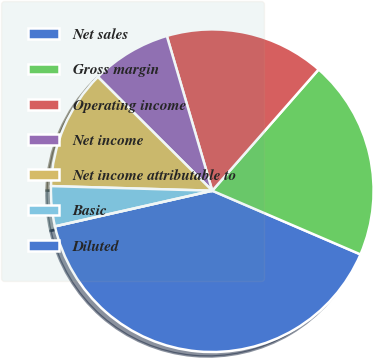<chart> <loc_0><loc_0><loc_500><loc_500><pie_chart><fcel>Net sales<fcel>Gross margin<fcel>Operating income<fcel>Net income<fcel>Net income attributable to<fcel>Basic<fcel>Diluted<nl><fcel>39.99%<fcel>20.0%<fcel>16.0%<fcel>8.0%<fcel>12.0%<fcel>4.0%<fcel>0.0%<nl></chart> 